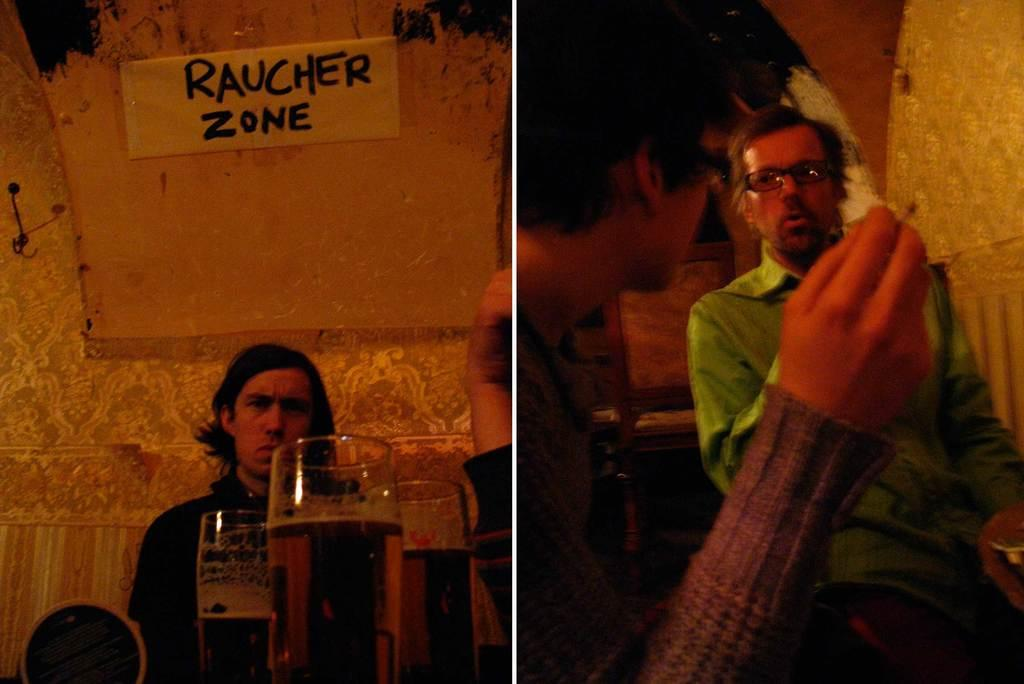<image>
Relay a brief, clear account of the picture shown. Males sitting together with a banner saying Raucher Zone. 